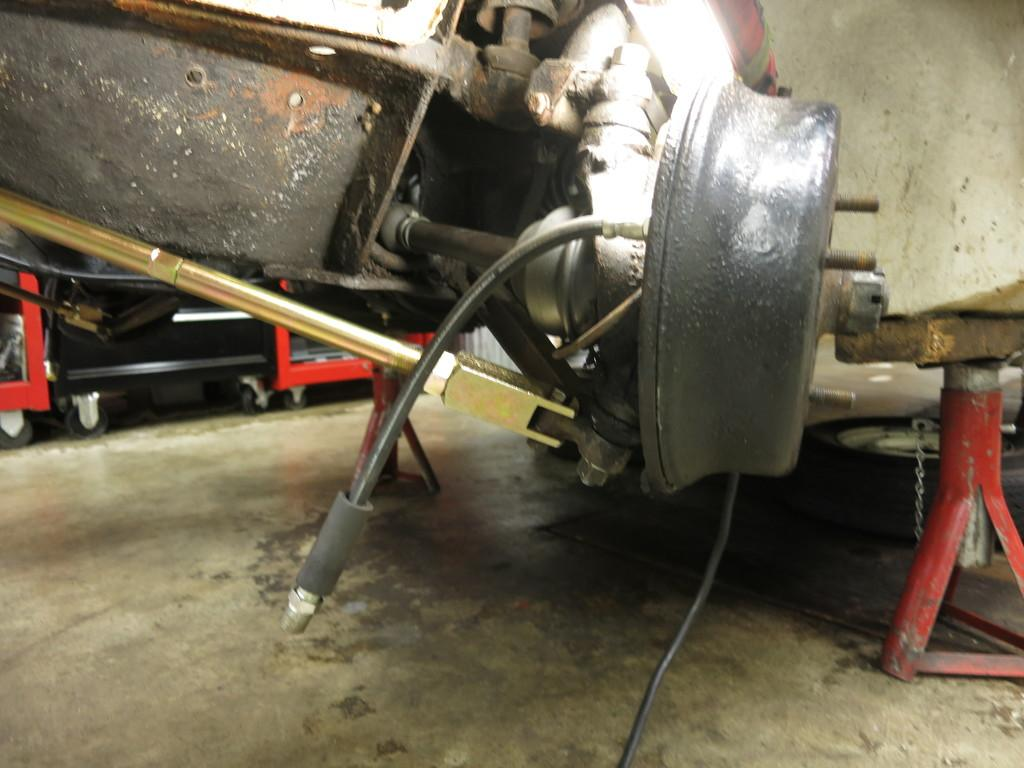What type of vehicle component is shown in the image? The image contains a vehicle's rim. What other object can be seen in the image besides the rim? There is a cable visible in the image. What is used to support the rim in the image? A stand is present in the image to support the rim. What part of the vehicle is responsible for converting force into linear motion? A piston is visible in the image. What other vehicle-related objects are present in the image? Other vehicle-related objects are present, but their specific details are not mentioned in the provided facts. What can be seen in the background of the image? There is another machine in the background. What is visible at the bottom of the image? The floor is visible at the bottom of the image. How many bottles of cord are stored in the cellar in the image? There is no cellar or bottles of cord present in the image. 